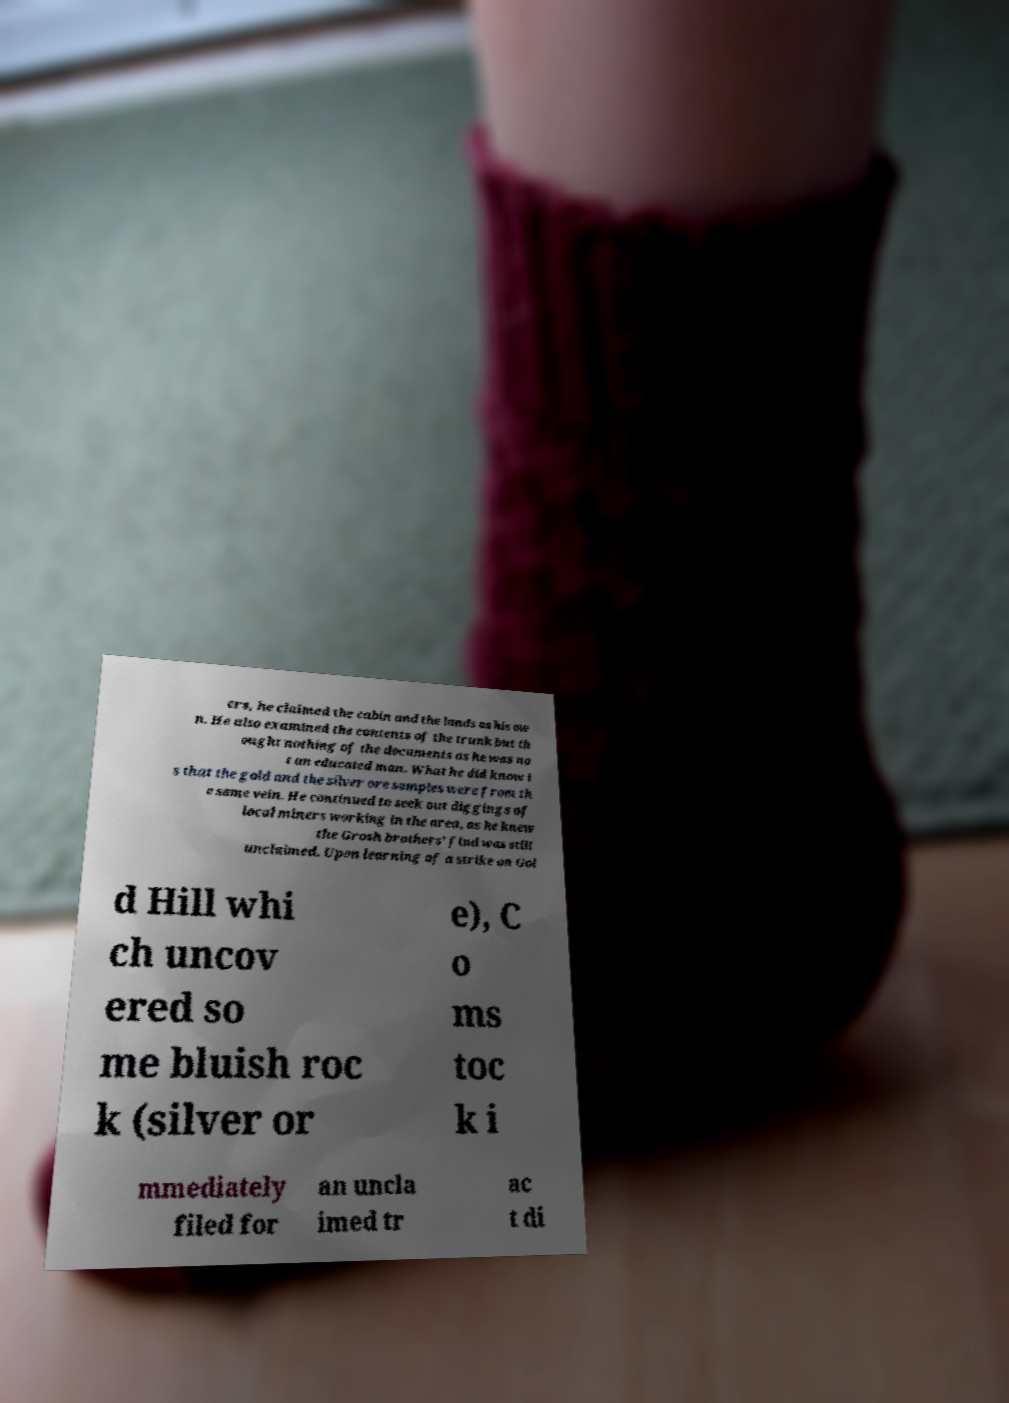Can you accurately transcribe the text from the provided image for me? ers, he claimed the cabin and the lands as his ow n. He also examined the contents of the trunk but th ought nothing of the documents as he was no t an educated man. What he did know i s that the gold and the silver ore samples were from th e same vein. He continued to seek out diggings of local miners working in the area, as he knew the Grosh brothers' find was still unclaimed. Upon learning of a strike on Gol d Hill whi ch uncov ered so me bluish roc k (silver or e), C o ms toc k i mmediately filed for an uncla imed tr ac t di 